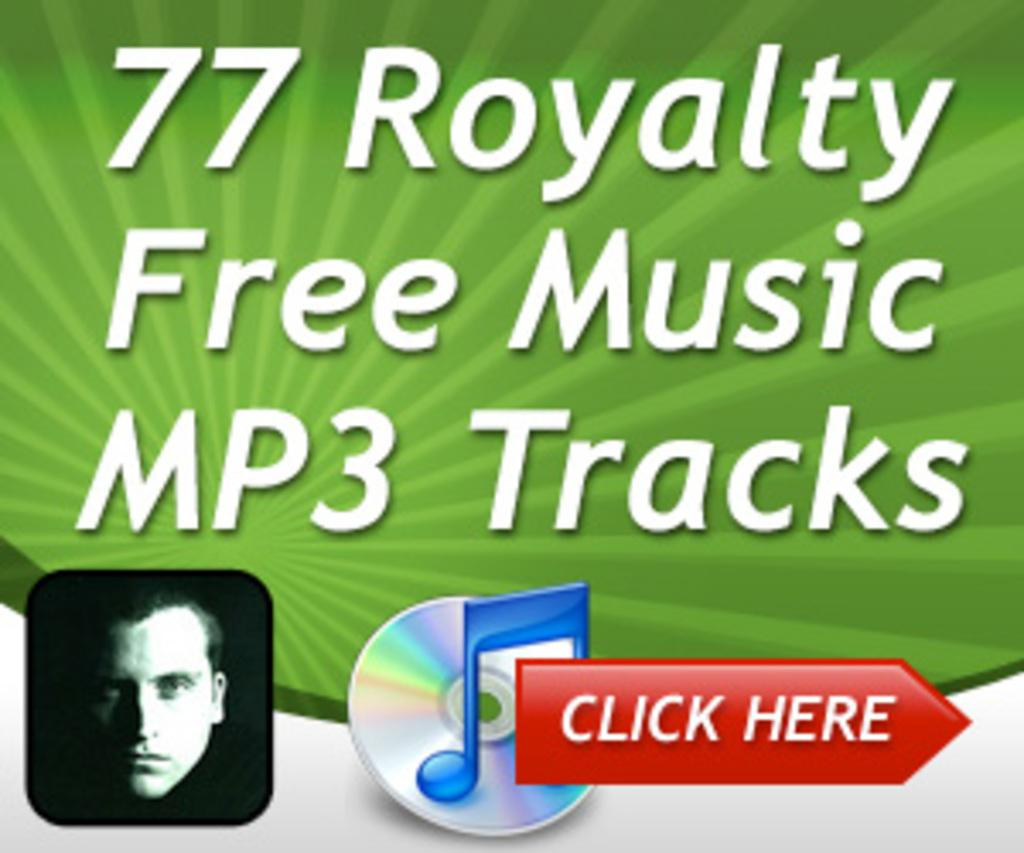What is present in the image that contains both an image and text? There is a poster in the image that contains an image and text. Can you describe the image on the poster? Unfortunately, the facts provided do not give any details about the image on the poster. What type of information might be conveyed by the text on the poster? The text on the poster could convey various types of information, such as a message, a title, or instructions. What month is being celebrated in the poster? There is no information about a month being celebrated in the poster, as the facts provided do not mention any specific month or event. 